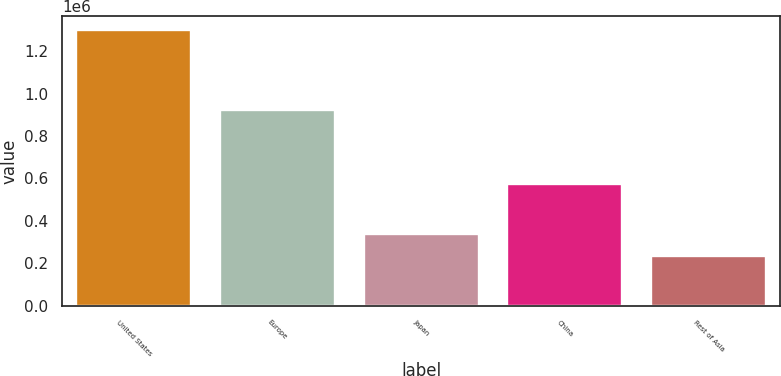Convert chart to OTSL. <chart><loc_0><loc_0><loc_500><loc_500><bar_chart><fcel>United States<fcel>Europe<fcel>Japan<fcel>China<fcel>Rest of Asia<nl><fcel>1.29963e+06<fcel>924849<fcel>340234<fcel>575690<fcel>233635<nl></chart> 